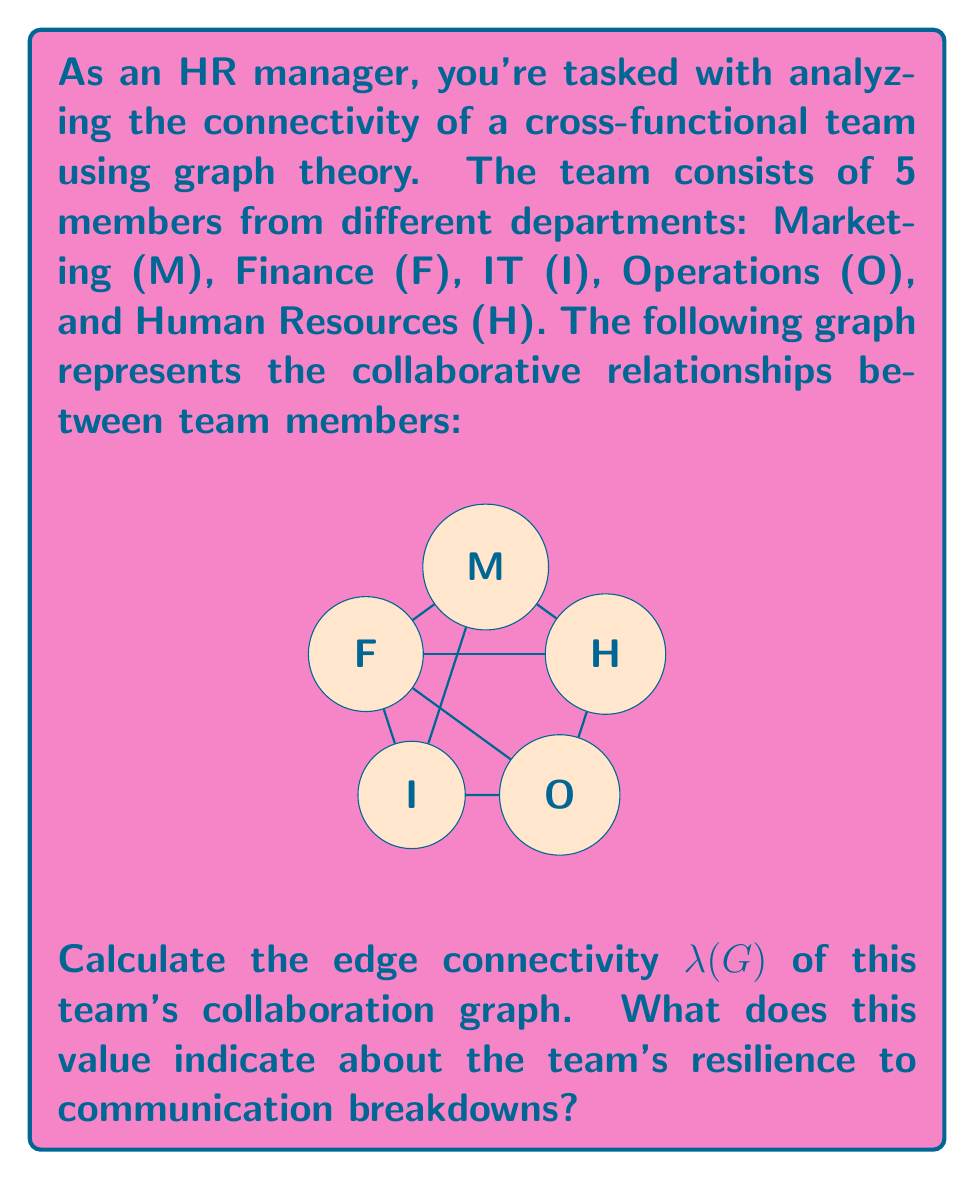What is the answer to this math problem? To solve this problem, we need to follow these steps:

1) First, let's recall the definition of edge connectivity $\lambda(G)$:
   The edge connectivity of a graph G is the minimum number of edges that need to be removed to disconnect the graph.

2) In this graph, we need to analyze various cut sets (sets of edges whose removal would disconnect the graph) and find the smallest one.

3) Let's examine potential cut sets:
   - Removing edges incident to M: 4 edges
   - Removing edges incident to F: 4 edges
   - Removing edges incident to I: 3 edges
   - Removing edges incident to O: 2 edges
   - Removing edges incident to H: 3 edges

4) We can also consider other sets of edges not incident to a single vertex:
   - Removing M-O and F-O: 2 edges

5) The smallest cut set we found consists of 2 edges: M-O and F-O.

6) Therefore, the edge connectivity $\lambda(G) = 2$.

7) Interpretation: This value indicates that the team's communication network can be disrupted by removing just 2 collaborative links. It suggests that the Operations member (O) is a potential weak point in the team's connectivity, as removing their connections to Marketing and Finance would isolate them from the rest of the team.

8) In terms of team resilience, a higher edge connectivity would indicate a more robust communication structure. With $\lambda(G) = 2$, this team has a relatively low resilience to communication breakdowns, and efforts should be made to strengthen connections, particularly those involving the Operations member.
Answer: $\lambda(G) = 2$ 